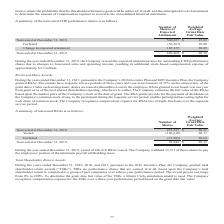According to Aci Worldwide's financial document, How many shares did the company withhold to pay  the employees' portion of the minimum payroll withholding taxes? According to the financial document, 32,371. The relevant text states: "otal of 106,610 RSAs vested. The Company withheld 32,371 of those shares to pay the employees’ portion of the minimum payroll withholding taxes. Total Share..." Also, What was the number of nonvested shares were there in 2018? According to the financial document, 213,337. The relevant text states: "Nonvested at December 31, 2018 213,337 $ 20.21..." Also, What was the Weighted Average Grant Date Fair Value of nonvested shares in 2018? According to the financial document, $20.21. The relevant text states: "Nonvested at December 31, 2018 213,337 $ 20.21..." Also, can you calculate: What is the change in nonvested shares between 2018 and 2019? Based on the calculation: 92,842-213,337, the result is -120495. This is based on the information: "Nonvested at December 31, 2019 92,842 $ 20.13 Nonvested at December 31, 2018 213,337 $ 20.21..." The key data points involved are: 213,337, 92,842. Also, can you calculate: What was the difference in Weighted Average Grant Date Fair Value between Vested and Forfeited shares? Based on the calculation: 20.64-20.17, the result is 0.47. This is based on the information: "Vested (106,610 ) 20.17 Forfeited (13,885 ) 20.64..." The key data points involved are: 20.17, 20.64. Also, can you calculate: What was the difference between the Weighted Average Grant Date Fair Value of nonvested shares in 2019 and forfeited shares? Based on the calculation: 20.64-20.13, the result is 0.51. This is based on the information: "Nonvested at December 31, 2019 92,842 $ 20.13 Forfeited (13,885 ) 20.64..." The key data points involved are: 20.13, 20.64. 